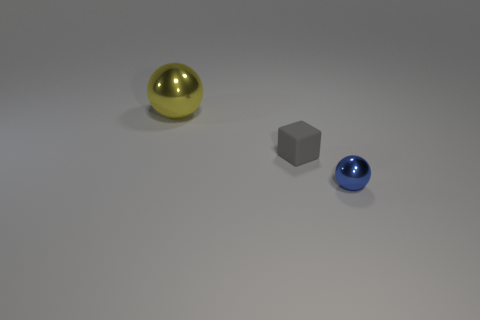Add 2 tiny cubes. How many objects exist? 5 Subtract all blocks. How many objects are left? 2 Subtract all yellow spheres. How many spheres are left? 1 Add 1 tiny blue objects. How many tiny blue objects are left? 2 Add 2 tiny gray objects. How many tiny gray objects exist? 3 Subtract 0 green cubes. How many objects are left? 3 Subtract all red balls. Subtract all purple cylinders. How many balls are left? 2 Subtract all gray metallic cylinders. Subtract all tiny rubber objects. How many objects are left? 2 